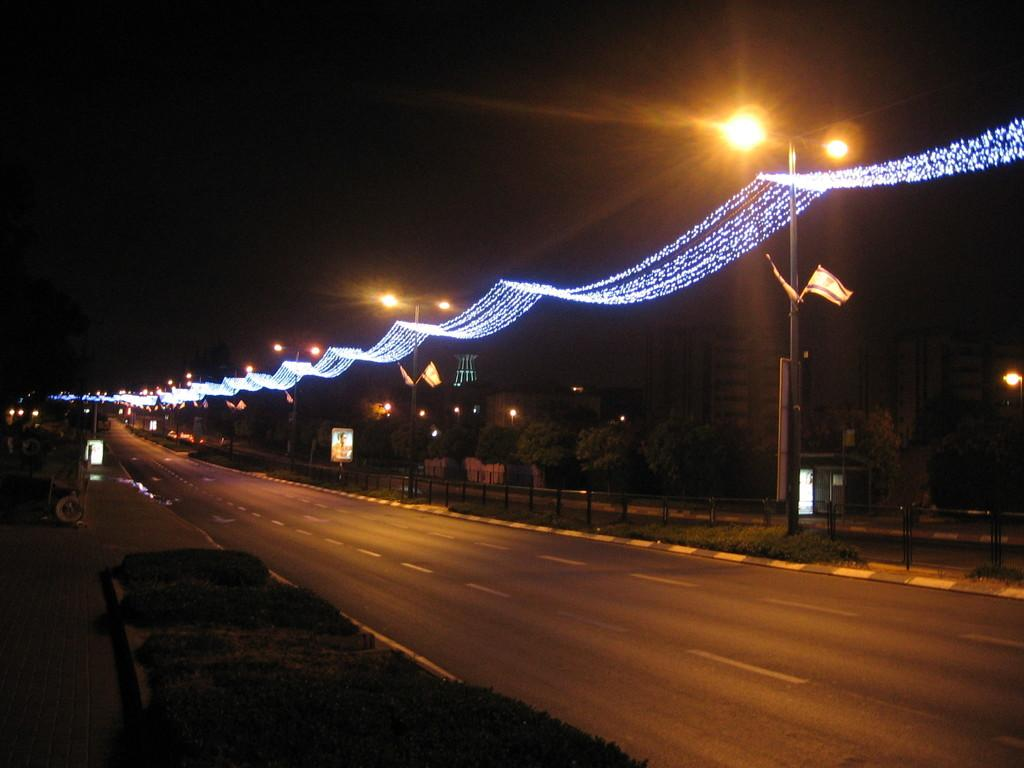What type of infrastructure can be seen in the image? There are roads in the image. What objects are present that might be used for construction or support? There are rods, poles, and boards in the image. What type of vegetation is visible in the image? There are trees and plants in the image. What type of illumination is present in the image? There are lights in the image. What type of symbolic objects can be seen in the image? There are flags in the image. What type of decorative objects can be seen in the image? There are decorative objects in the image. What is the color of the background in the image? The background of the image is dark. What type of coach can be seen driving on the sand in the image? There is no coach or sand present in the image. What type of machine is being used to dig up the ground in the image? There is no machine or digging activity present in the image. 